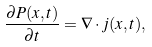<formula> <loc_0><loc_0><loc_500><loc_500>\frac { \partial P ( x , t ) } { \partial t } = \nabla \cdot j ( x , t ) ,</formula> 